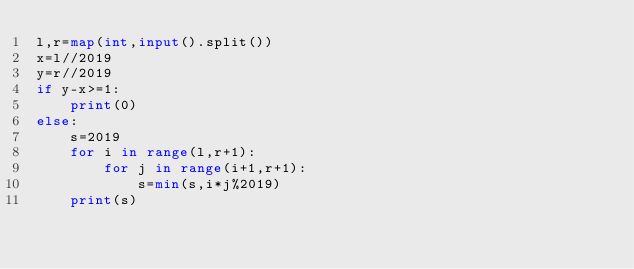<code> <loc_0><loc_0><loc_500><loc_500><_Python_>l,r=map(int,input().split())
x=l//2019
y=r//2019
if y-x>=1:
    print(0)
else:
    s=2019
    for i in range(l,r+1):
        for j in range(i+1,r+1):
            s=min(s,i*j%2019)
    print(s)</code> 